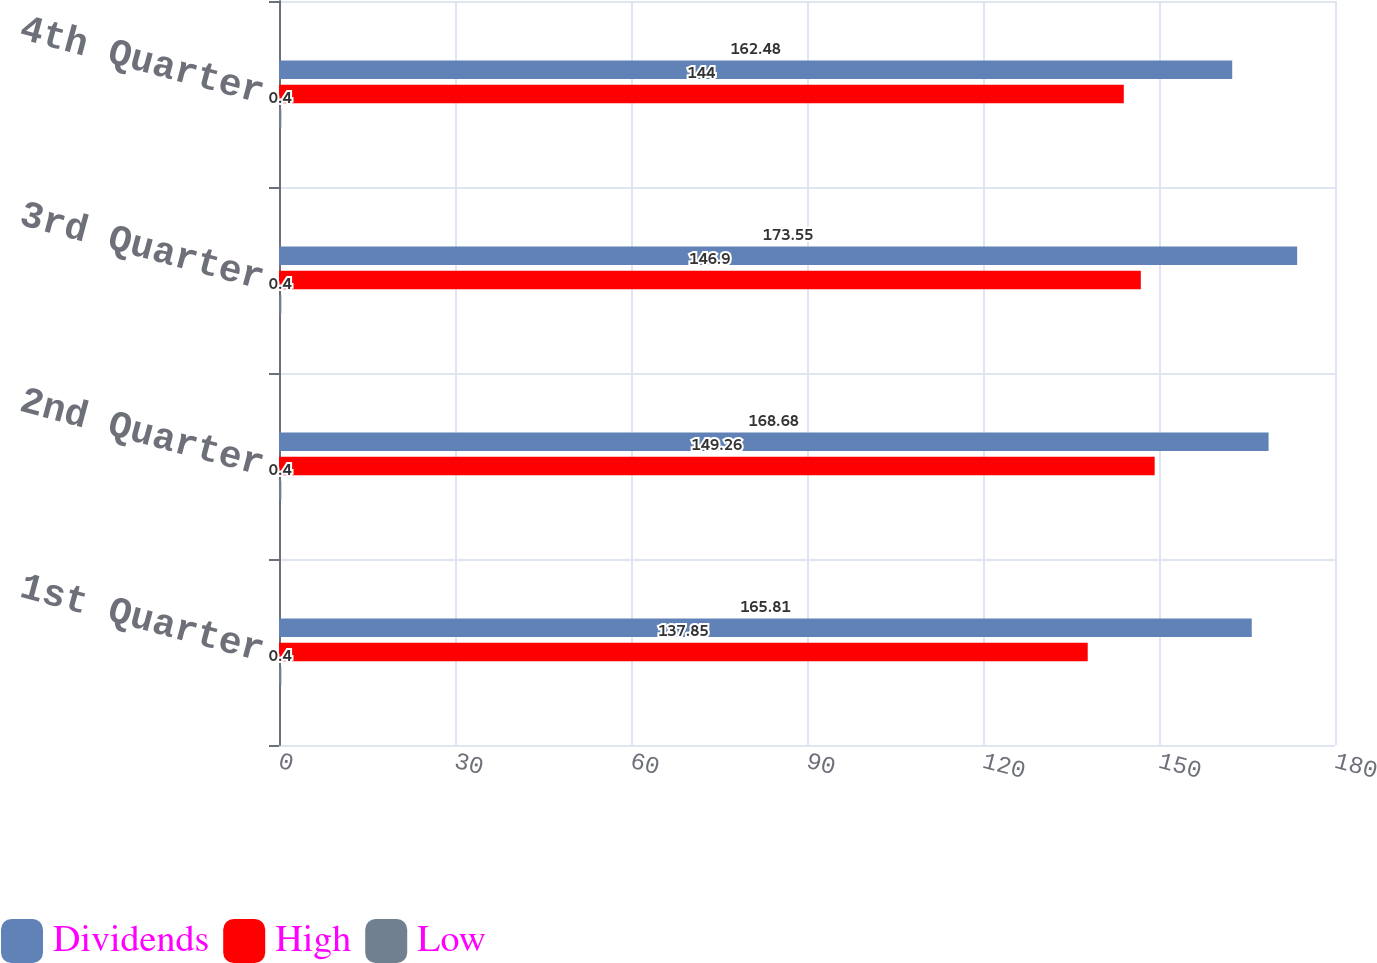<chart> <loc_0><loc_0><loc_500><loc_500><stacked_bar_chart><ecel><fcel>1st Quarter<fcel>2nd Quarter<fcel>3rd Quarter<fcel>4th Quarter<nl><fcel>Dividends<fcel>165.81<fcel>168.68<fcel>173.55<fcel>162.48<nl><fcel>High<fcel>137.85<fcel>149.26<fcel>146.9<fcel>144<nl><fcel>Low<fcel>0.4<fcel>0.4<fcel>0.4<fcel>0.4<nl></chart> 